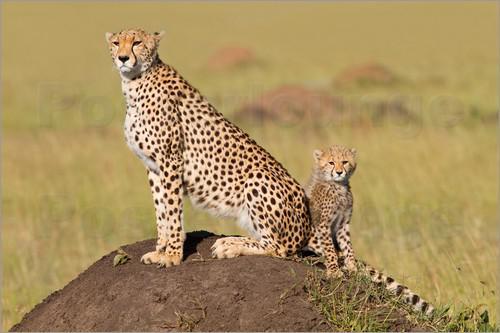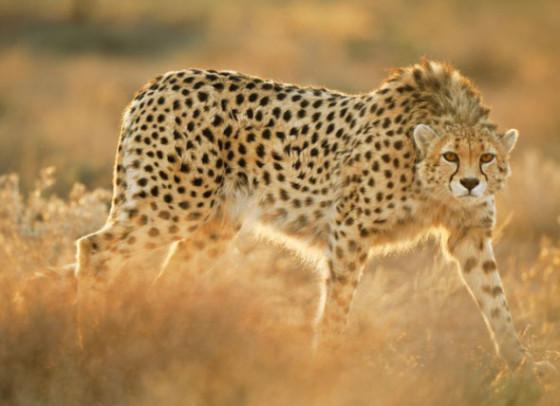The first image is the image on the left, the second image is the image on the right. For the images displayed, is the sentence "In one of the images there is a leopard lying on the ground." factually correct? Answer yes or no. No. 